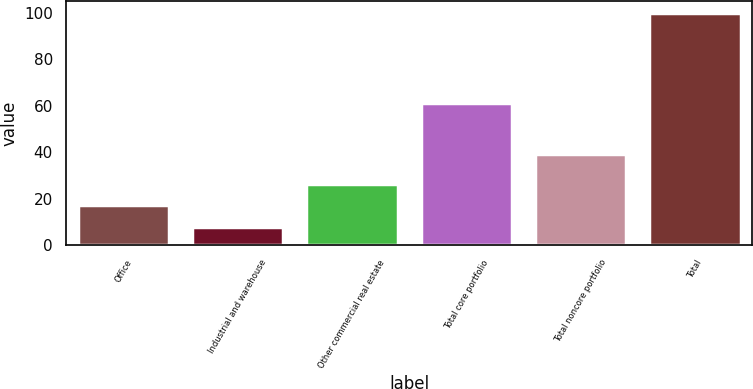Convert chart to OTSL. <chart><loc_0><loc_0><loc_500><loc_500><bar_chart><fcel>Office<fcel>Industrial and warehouse<fcel>Other commercial real estate<fcel>Total core portfolio<fcel>Total noncore portfolio<fcel>Total<nl><fcel>17.2<fcel>8<fcel>26.4<fcel>61<fcel>39<fcel>100<nl></chart> 